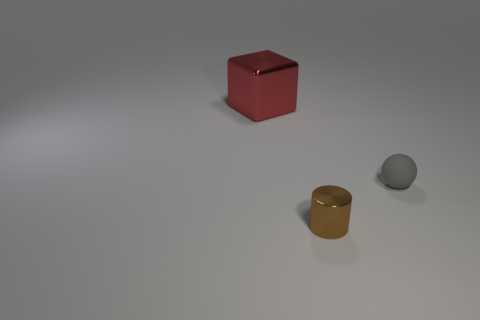Add 2 small cyan balls. How many objects exist? 5 Subtract all spheres. How many objects are left? 2 Subtract all tiny yellow rubber cubes. Subtract all metal things. How many objects are left? 1 Add 1 large metal things. How many large metal things are left? 2 Add 3 big blue balls. How many big blue balls exist? 3 Subtract 0 green balls. How many objects are left? 3 Subtract all yellow cylinders. Subtract all gray cubes. How many cylinders are left? 1 